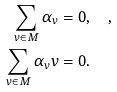<formula> <loc_0><loc_0><loc_500><loc_500>\sum _ { v \in M } \alpha _ { v } & = 0 , \quad , \\ \sum _ { v \in M } \alpha _ { v } v & = 0 .</formula> 